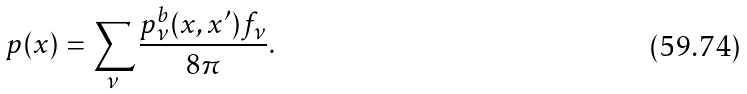<formula> <loc_0><loc_0><loc_500><loc_500>p ( x ) = \sum _ { \nu } \frac { p ^ { b } _ { \nu } ( x , x ^ { \prime } ) f _ { \nu } } { 8 \pi } .</formula> 